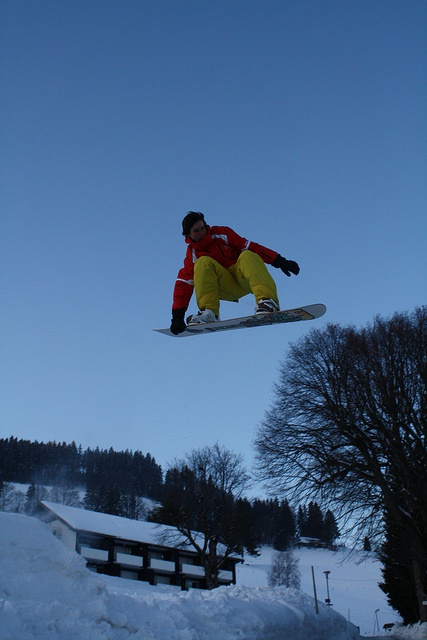Describe the objects in this image and their specific colors. I can see people in blue, black, darkgreen, maroon, and gray tones and snowboard in blue, black, and navy tones in this image. 